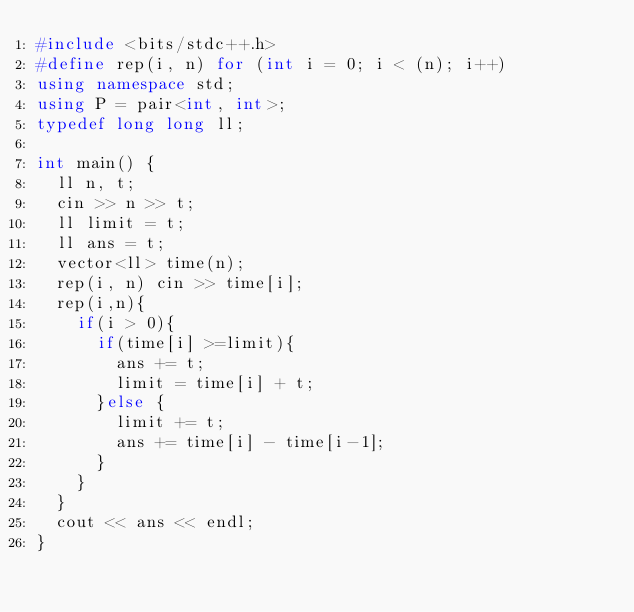<code> <loc_0><loc_0><loc_500><loc_500><_C++_>#include <bits/stdc++.h>
#define rep(i, n) for (int i = 0; i < (n); i++)
using namespace std;
using P = pair<int, int>;
typedef long long ll;

int main() {
  ll n, t;
  cin >> n >> t;
  ll limit = t;
  ll ans = t;
  vector<ll> time(n);
  rep(i, n) cin >> time[i];
  rep(i,n){
    if(i > 0){
      if(time[i] >=limit){
        ans += t;
        limit = time[i] + t;
      }else {
        limit += t;
        ans += time[i] - time[i-1];
      }
    }
  }
  cout << ans << endl;
}</code> 